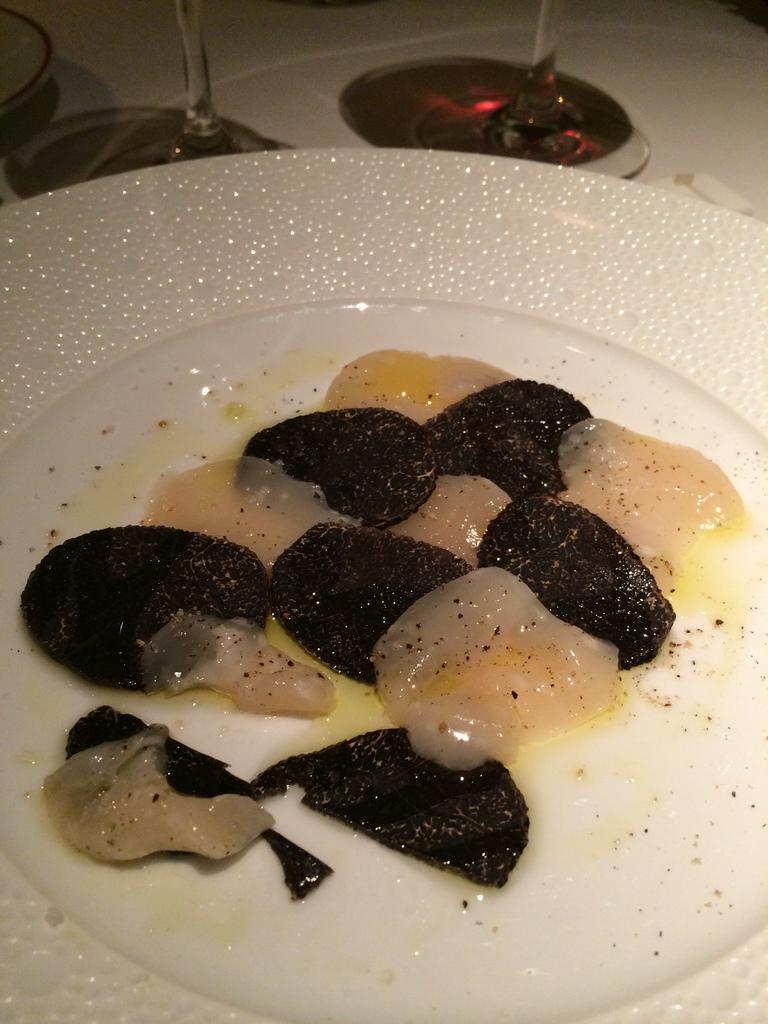Describe this image in one or two sentences. In this image, we can see some food items in a plate. We can also see some glass objects at the top. We can also see an object on the left. 